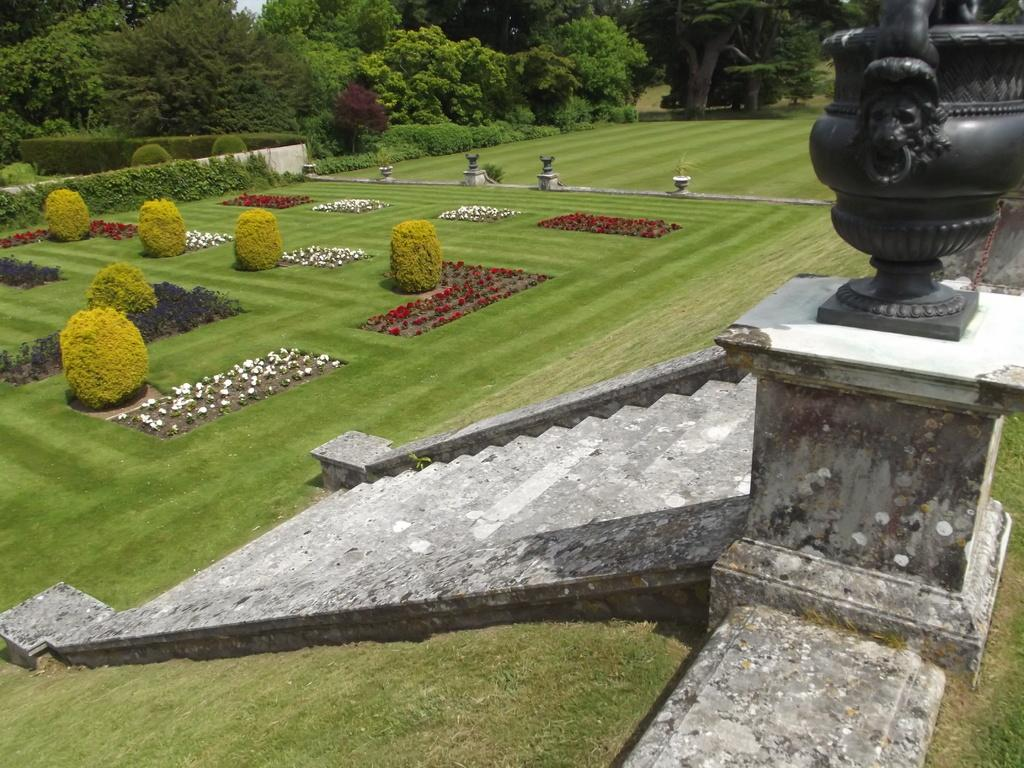What type of natural elements can be seen in the image? There are trees in the back side of the image. What architectural feature is located in the middle of the image? There is a staircase in the middle of the image. What object is on the right side of the image? There is a statue on the right side of the image. What type of appliance can be seen on the left side of the image? There is no appliance present on the left side of the image. Can you tell me the name of the aunt who is standing next to the statue in the image? There is no person, let alone an aunt, present in the image. 